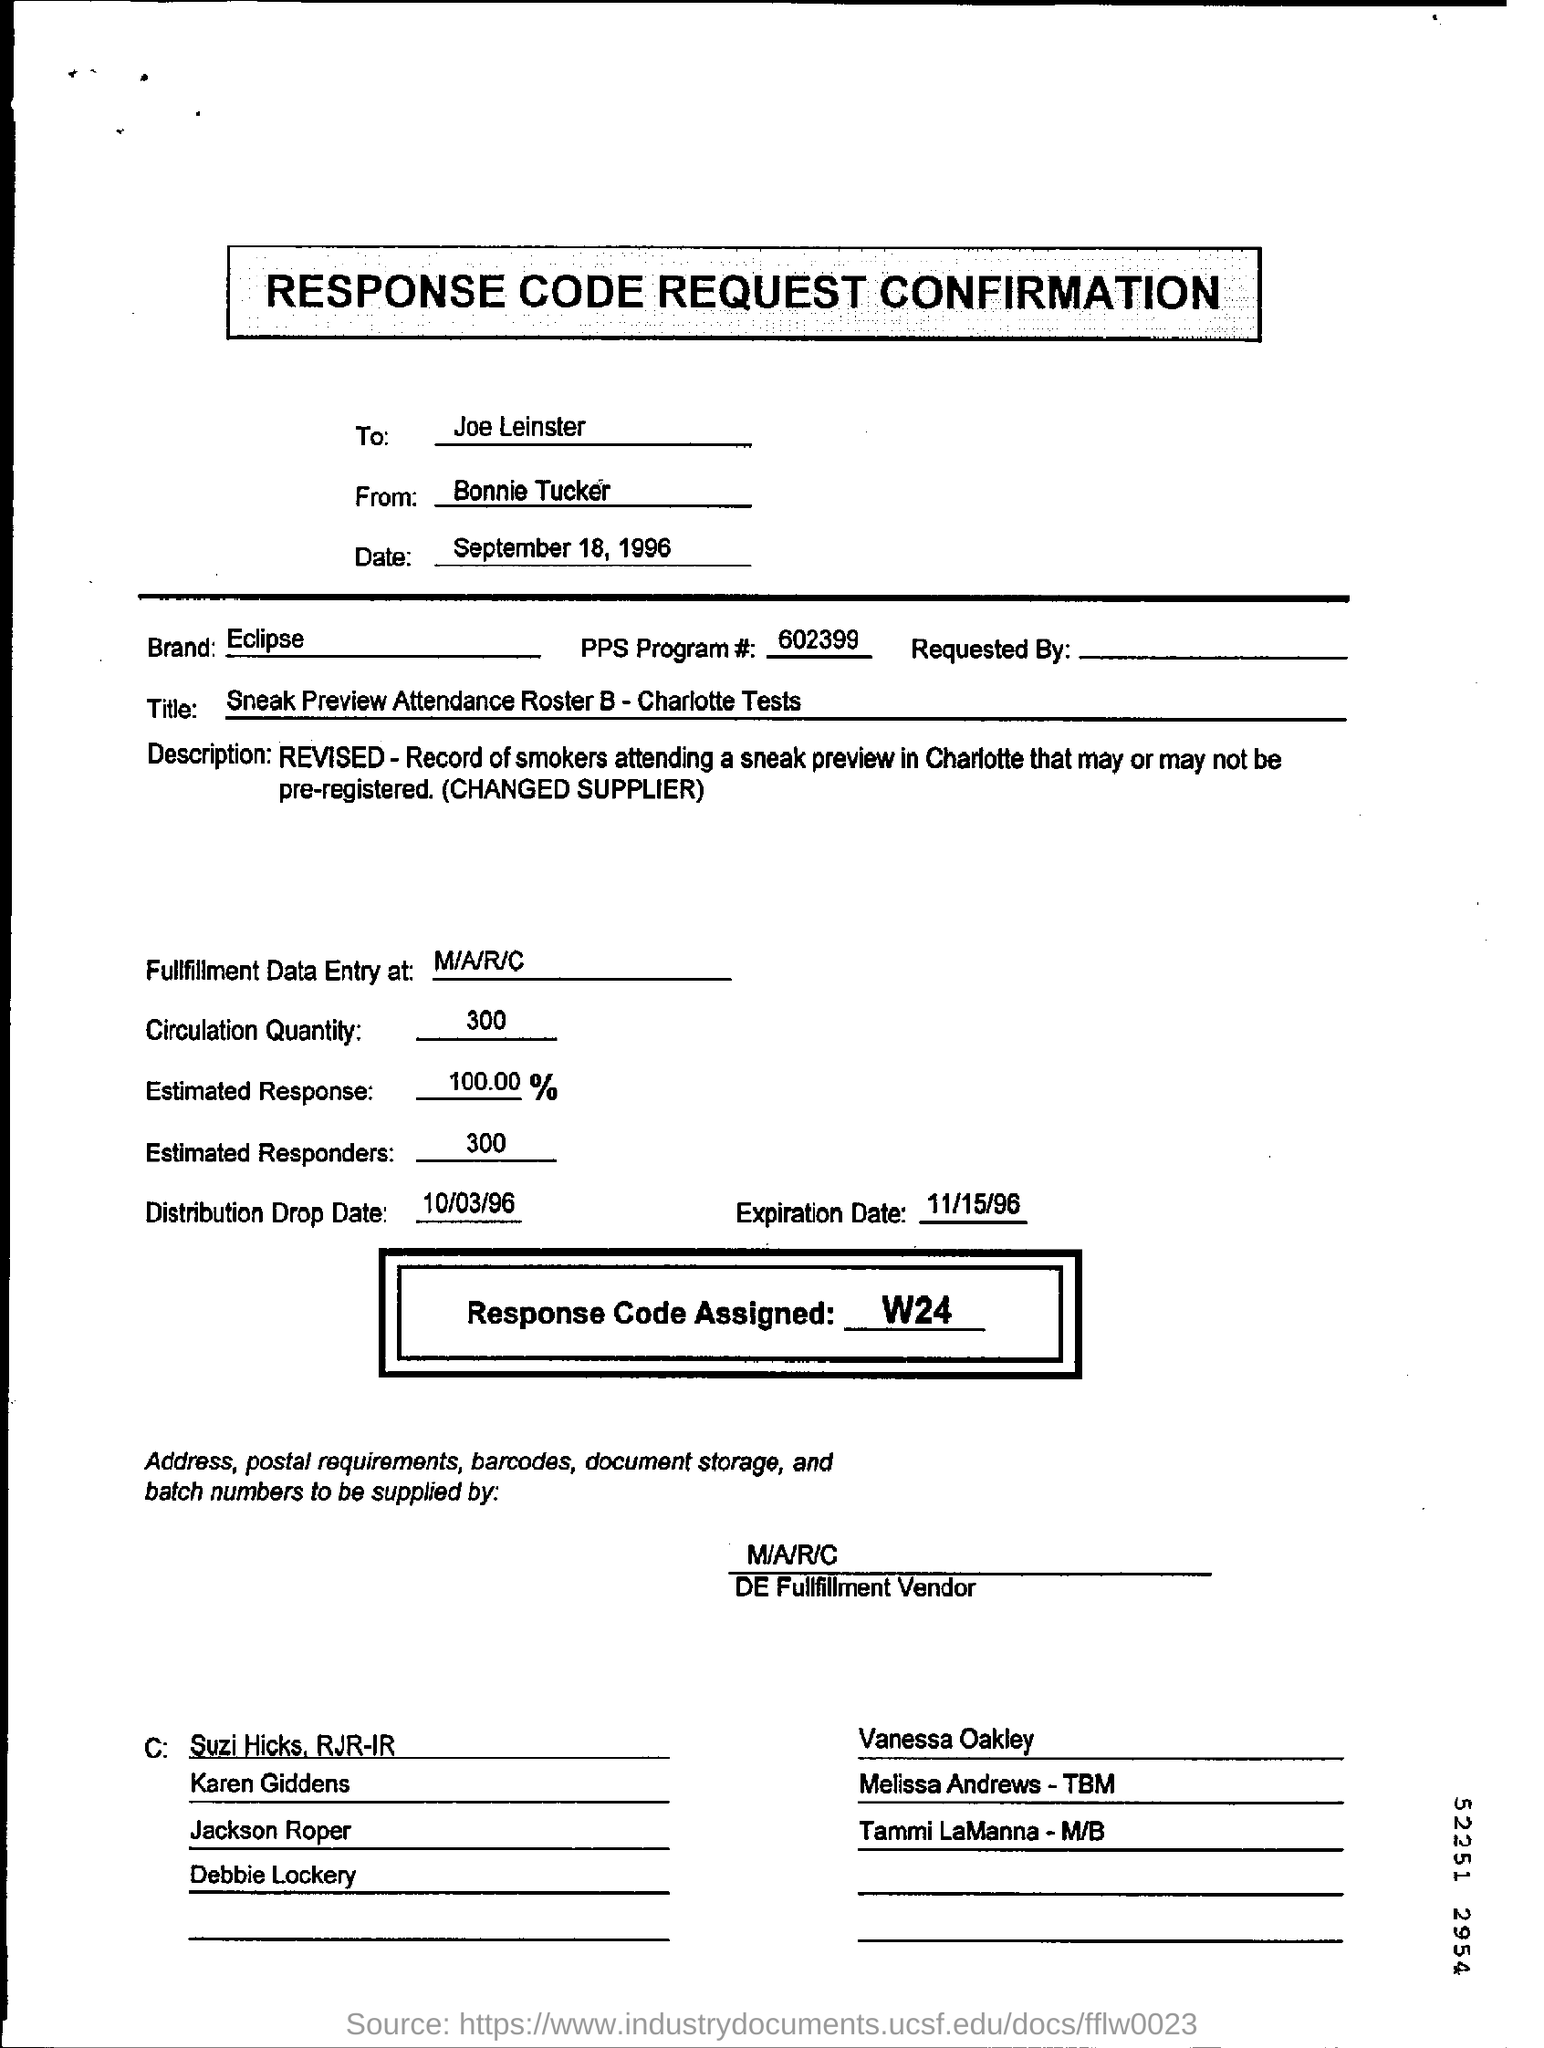What is the date mentioned in the form?
Your response must be concise. September 18, 1996. What is the PPS Program #?
Offer a very short reply. 602399. What is the Circulation Qty mentioned?
Your answer should be very brief. 300. What is the Estimated Response mentioned?
Your response must be concise. 100.00%. 